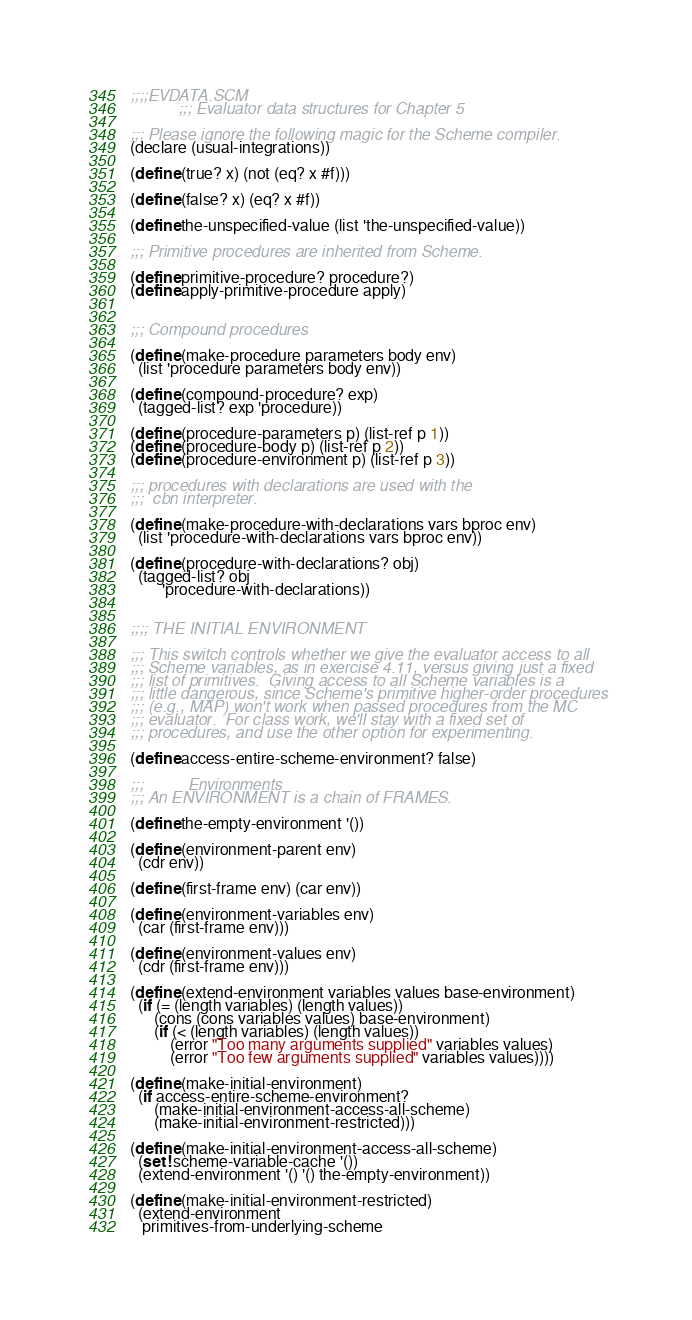Convert code to text. <code><loc_0><loc_0><loc_500><loc_500><_Scheme_>;;;;EVDATA.SCM
            ;;; Evaluator data structures for Chapter 5

;;; Please ignore the following magic for the Scheme compiler.
(declare (usual-integrations))

(define (true? x) (not (eq? x #f)))

(define (false? x) (eq? x #f))

(define the-unspecified-value (list 'the-unspecified-value))

;;; Primitive procedures are inherited from Scheme.

(define primitive-procedure? procedure?)
(define apply-primitive-procedure apply)


;;; Compound procedures

(define (make-procedure parameters body env)
  (list 'procedure parameters body env))

(define (compound-procedure? exp)
  (tagged-list? exp 'procedure))

(define (procedure-parameters p) (list-ref p 1))
(define (procedure-body p) (list-ref p 2))
(define (procedure-environment p) (list-ref p 3))

;;; procedures with declarations are used with the
;;;  cbn interpreter.

(define (make-procedure-with-declarations vars bproc env)
  (list 'procedure-with-declarations vars bproc env))

(define (procedure-with-declarations? obj)
  (tagged-list? obj
		'procedure-with-declarations))


;;;; THE INITIAL ENVIRONMENT

;;; This switch controls whether we give the evaluator access to all
;;; Scheme variables, as in exercise 4.11, versus giving just a fixed
;;; list of primitives.  Giving access to all Scheme variables is a
;;; little dangerous, since Scheme's primitive higher-order procedures
;;; (e.g., MAP) won't work when passed procedures from the MC
;;; evaluator.  For class work, we'll stay with a fixed set of
;;; procedures, and use the other option for experimenting.

(define access-entire-scheme-environment? false)

;;;          Environments
;;; An ENVIRONMENT is a chain of FRAMES.

(define the-empty-environment '())

(define (environment-parent env)
  (cdr env))

(define (first-frame env) (car env))

(define (environment-variables env)
  (car (first-frame env)))

(define (environment-values env)
  (cdr (first-frame env)))

(define (extend-environment variables values base-environment)
  (if (= (length variables) (length values))
      (cons (cons variables values) base-environment)
      (if (< (length variables) (length values))
          (error "Too many arguments supplied" variables values)
          (error "Too few arguments supplied" variables values))))

(define (make-initial-environment)
  (if access-entire-scheme-environment?
      (make-initial-environment-access-all-scheme)
      (make-initial-environment-restricted)))

(define (make-initial-environment-access-all-scheme)
  (set! scheme-variable-cache '())
  (extend-environment '() '() the-empty-environment))

(define (make-initial-environment-restricted)
  (extend-environment
   primitives-from-underlying-scheme</code> 